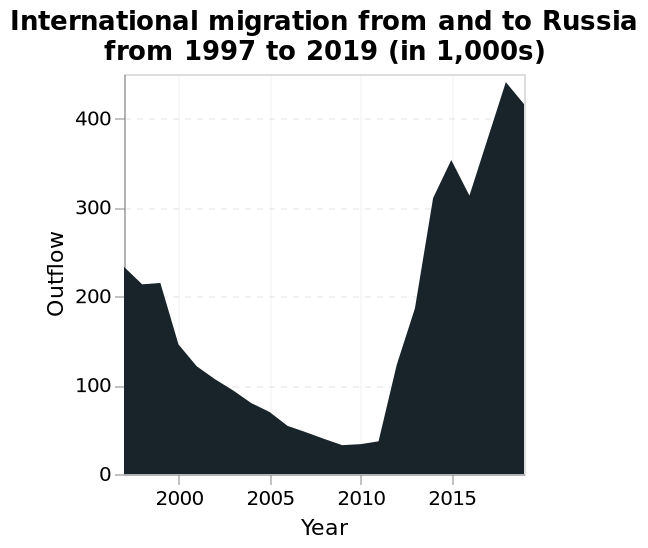<image>
What is the label on the x-axis of the area graph? The label on the x-axis of the area graph is "Year." What was the population in the year 2010?  The population in the year 2010 was 50,000. 